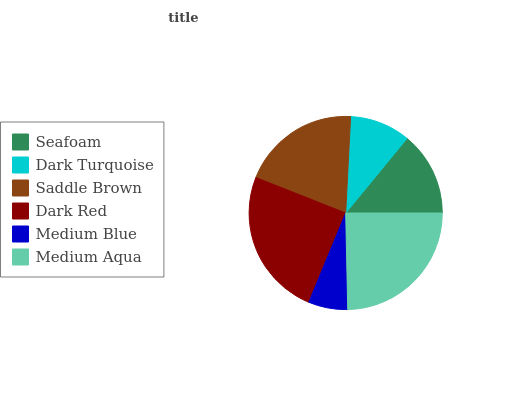Is Medium Blue the minimum?
Answer yes or no. Yes. Is Dark Red the maximum?
Answer yes or no. Yes. Is Dark Turquoise the minimum?
Answer yes or no. No. Is Dark Turquoise the maximum?
Answer yes or no. No. Is Seafoam greater than Dark Turquoise?
Answer yes or no. Yes. Is Dark Turquoise less than Seafoam?
Answer yes or no. Yes. Is Dark Turquoise greater than Seafoam?
Answer yes or no. No. Is Seafoam less than Dark Turquoise?
Answer yes or no. No. Is Saddle Brown the high median?
Answer yes or no. Yes. Is Seafoam the low median?
Answer yes or no. Yes. Is Seafoam the high median?
Answer yes or no. No. Is Saddle Brown the low median?
Answer yes or no. No. 